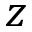Convert formula to latex. <formula><loc_0><loc_0><loc_500><loc_500>z</formula> 